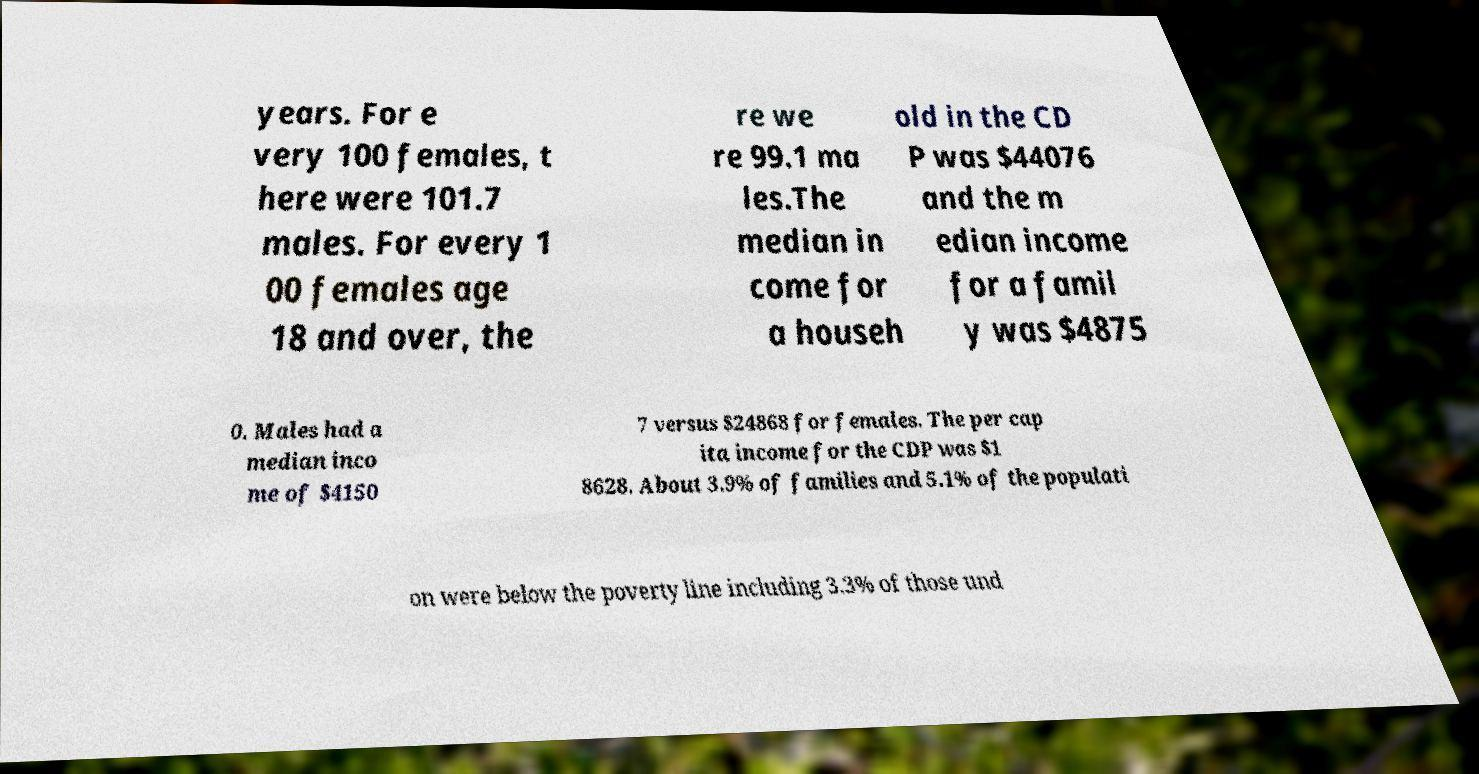Please identify and transcribe the text found in this image. years. For e very 100 females, t here were 101.7 males. For every 1 00 females age 18 and over, the re we re 99.1 ma les.The median in come for a househ old in the CD P was $44076 and the m edian income for a famil y was $4875 0. Males had a median inco me of $4150 7 versus $24868 for females. The per cap ita income for the CDP was $1 8628. About 3.9% of families and 5.1% of the populati on were below the poverty line including 3.3% of those und 